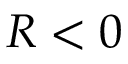<formula> <loc_0><loc_0><loc_500><loc_500>R < 0</formula> 